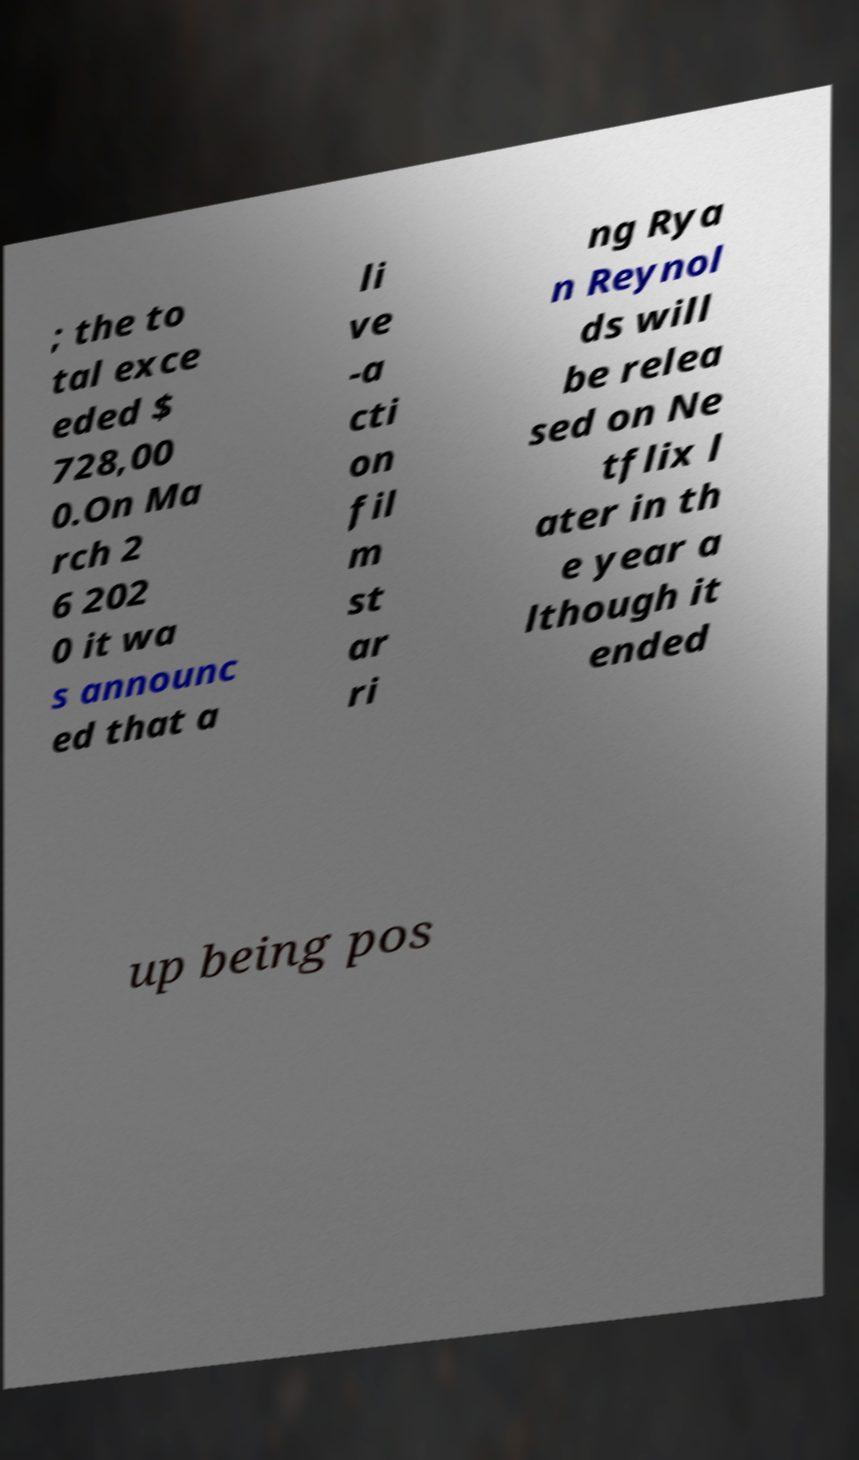Could you assist in decoding the text presented in this image and type it out clearly? ; the to tal exce eded $ 728,00 0.On Ma rch 2 6 202 0 it wa s announc ed that a li ve -a cti on fil m st ar ri ng Rya n Reynol ds will be relea sed on Ne tflix l ater in th e year a lthough it ended up being pos 